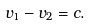Convert formula to latex. <formula><loc_0><loc_0><loc_500><loc_500>v _ { 1 } - v _ { 2 } = c .</formula> 